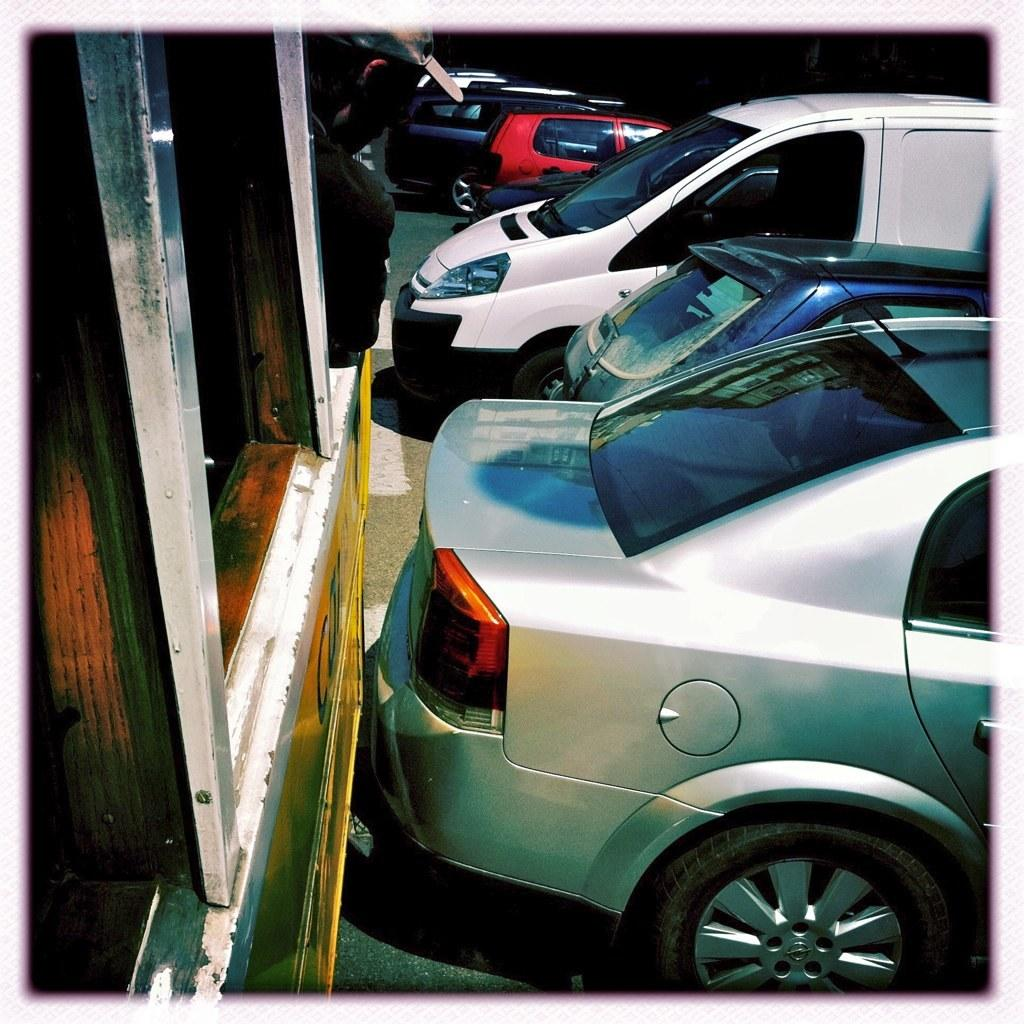What can be seen on the road in the image? There are vehicles on the road in the image. Can you describe the person visible at the top of the image? The person is wearing a cap. What type of thread is being used by the cow in the image? There is no cow present in the image, so it is not possible to determine what type of thread might be used. 